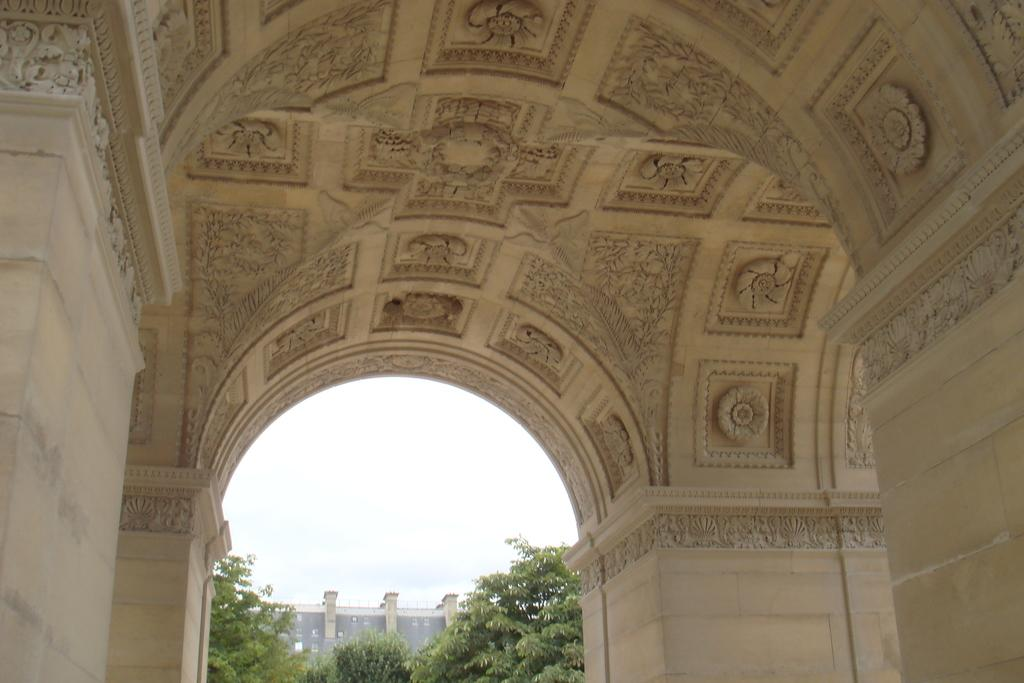What architectural features can be seen in the image? There are pillars in the image. What can be observed on the roof of the building in the image? There are designs on the roof in the image. What type of vegetation is present in the image? There are trees in the image. What type of structure is depicted in the image? There is a building in the image. What is visible in the background of the image? The sky is visible in the background of the image. Can you see any feathers floating in the sea in the image? There is no sea or feathers present in the image. 